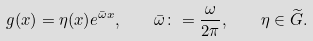<formula> <loc_0><loc_0><loc_500><loc_500>g ( x ) = \eta ( x ) e ^ { \bar { \omega } x } , \quad \bar { \omega } \colon = \frac { \omega } { 2 \pi } , \quad \eta \in \widetilde { G } .</formula> 